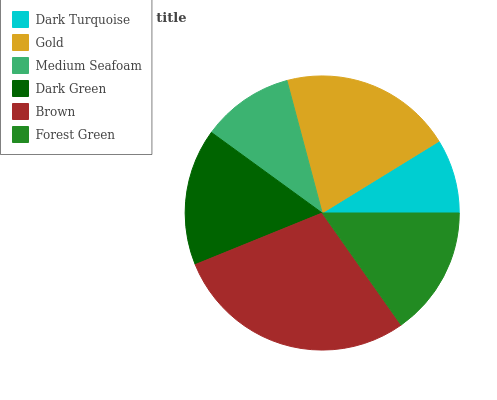Is Dark Turquoise the minimum?
Answer yes or no. Yes. Is Brown the maximum?
Answer yes or no. Yes. Is Gold the minimum?
Answer yes or no. No. Is Gold the maximum?
Answer yes or no. No. Is Gold greater than Dark Turquoise?
Answer yes or no. Yes. Is Dark Turquoise less than Gold?
Answer yes or no. Yes. Is Dark Turquoise greater than Gold?
Answer yes or no. No. Is Gold less than Dark Turquoise?
Answer yes or no. No. Is Dark Green the high median?
Answer yes or no. Yes. Is Forest Green the low median?
Answer yes or no. Yes. Is Brown the high median?
Answer yes or no. No. Is Medium Seafoam the low median?
Answer yes or no. No. 